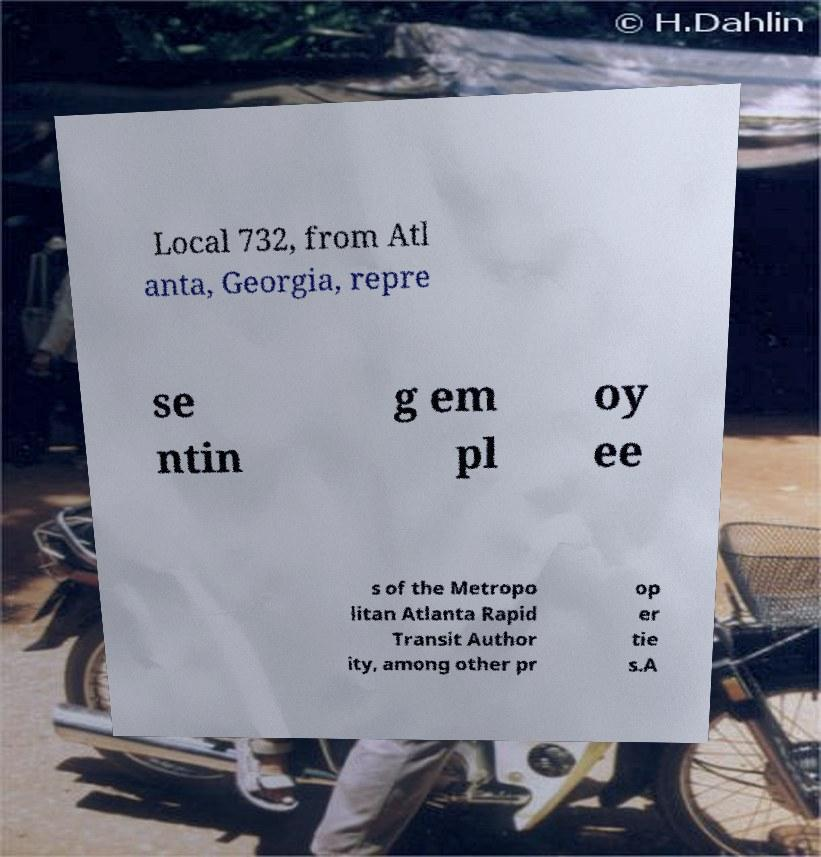There's text embedded in this image that I need extracted. Can you transcribe it verbatim? Local 732, from Atl anta, Georgia, repre se ntin g em pl oy ee s of the Metropo litan Atlanta Rapid Transit Author ity, among other pr op er tie s.A 